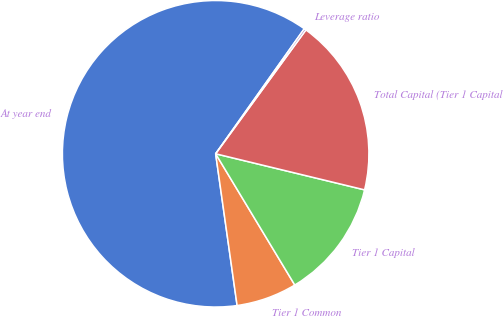<chart> <loc_0><loc_0><loc_500><loc_500><pie_chart><fcel>At year end<fcel>Tier 1 Common<fcel>Tier 1 Capital<fcel>Total Capital (Tier 1 Capital<fcel>Leverage ratio<nl><fcel>62.05%<fcel>6.4%<fcel>12.58%<fcel>18.76%<fcel>0.21%<nl></chart> 